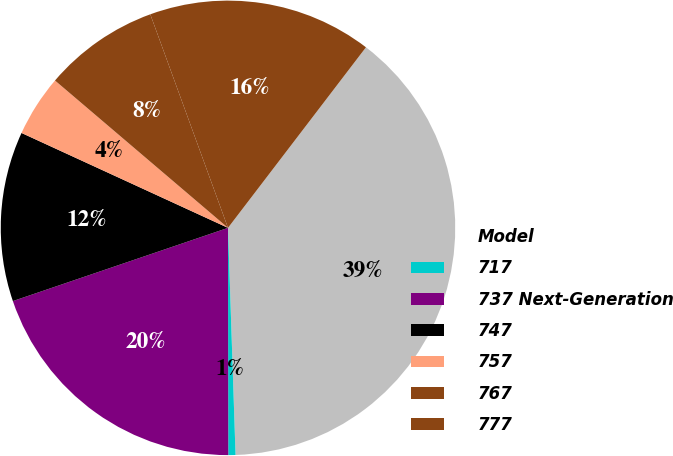Convert chart. <chart><loc_0><loc_0><loc_500><loc_500><pie_chart><fcel>Model<fcel>717<fcel>737 Next-Generation<fcel>747<fcel>757<fcel>767<fcel>777<nl><fcel>39.09%<fcel>0.51%<fcel>19.8%<fcel>12.08%<fcel>4.37%<fcel>8.22%<fcel>15.94%<nl></chart> 